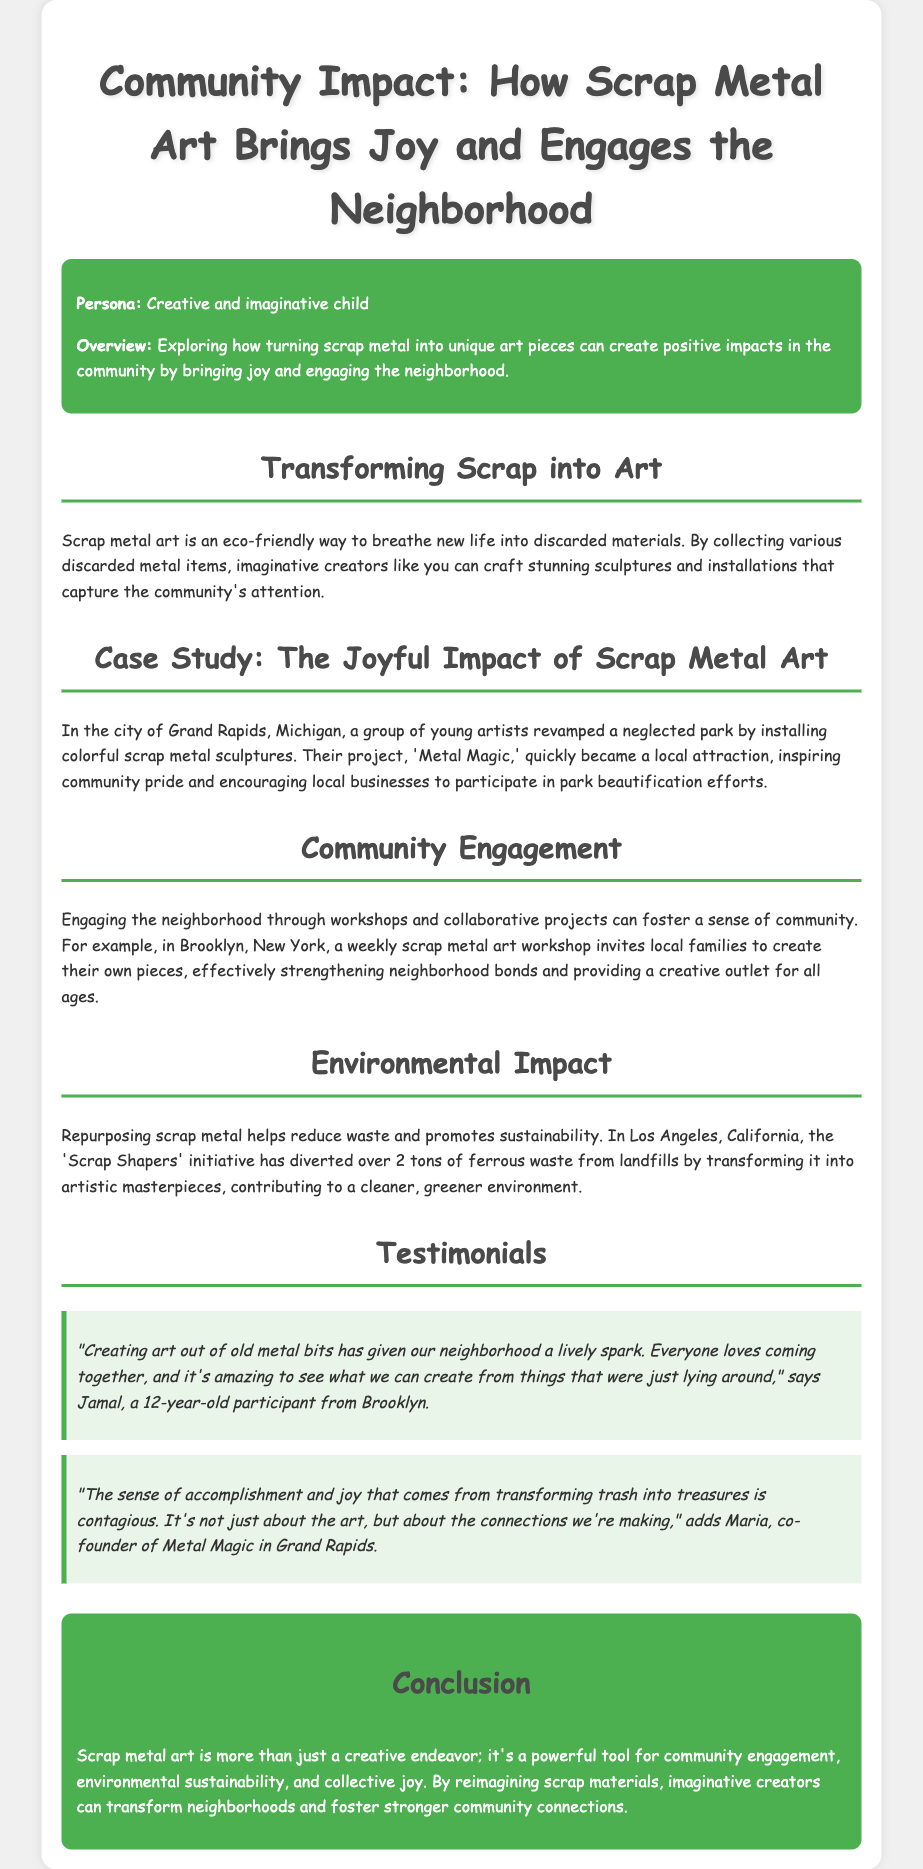What is the title of the case study? The title of the case study is prominently displayed at the top of the document, introducing the main topic of discussion.
Answer: Community Impact: How Scrap Metal Art Brings Joy and Engages the Neighborhood Where is the 'Metal Magic' project located? The document specifies the location of the 'Metal Magic' project, indicating where the community initiative took place.
Answer: Grand Rapids, Michigan What is the aim of the weekly scrap metal art workshop in Brooklyn? The document highlights the purpose of the workshop, focusing on community engagement and creative participation among families.
Answer: To create their own pieces How many tons of waste has the 'Scrap Shapers' initiative diverted? The document provides a specific numerical detail regarding the environmental impact of the initiative mentioned in Los Angeles.
Answer: Over 2 tons Who is Jamal? The document includes testimonials and identifies Jamal as a participant, specifying his age and location.
Answer: A 12-year-old participant from Brooklyn What is one key benefit of scrap metal art mentioned in the conclusion? The conclusion summarizes the overall impact of scrap metal art, emphasizing its benefits to the community.
Answer: Community engagement What color theme is used in the introduction section? The document describes the background color used for the introduction section that enhances the overall visual appeal.
Answer: Green What is the name of the initiative in Los Angeles? The document specifies the initiative focused on scrap metal art in Los Angeles.
Answer: Scrap Shapers 